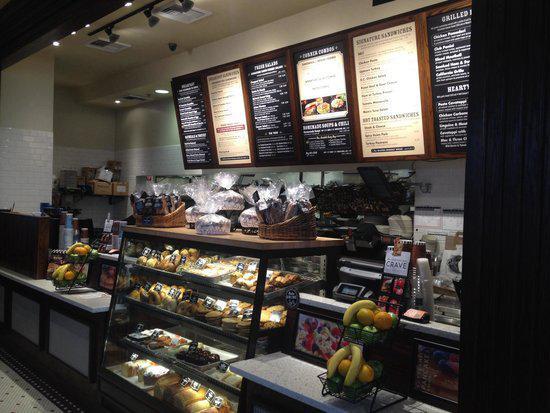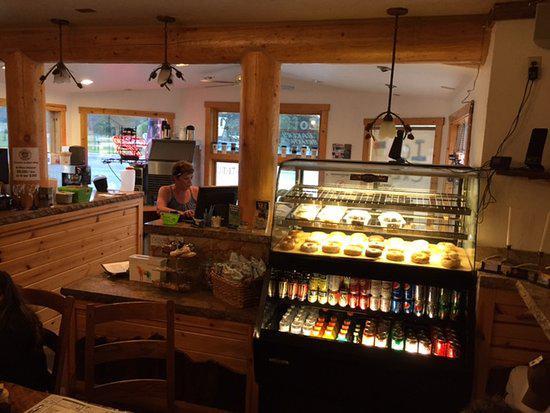The first image is the image on the left, the second image is the image on the right. For the images shown, is this caption "At least one person is standing at a counter and at least one person is sitting at a table with wood chairs around it in one image." true? Answer yes or no. Yes. 